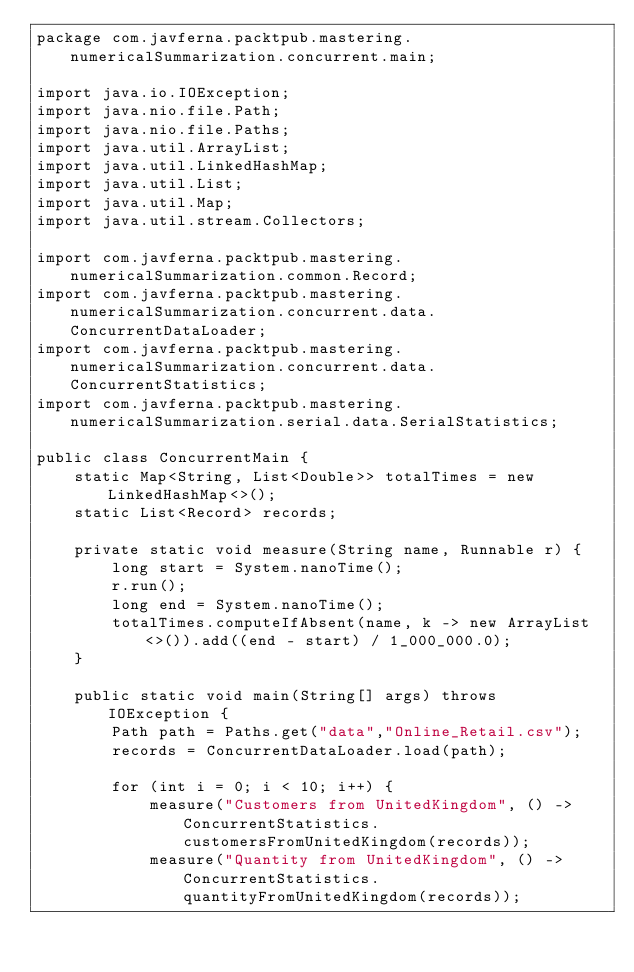Convert code to text. <code><loc_0><loc_0><loc_500><loc_500><_Java_>package com.javferna.packtpub.mastering.numericalSummarization.concurrent.main;

import java.io.IOException;
import java.nio.file.Path;
import java.nio.file.Paths;
import java.util.ArrayList;
import java.util.LinkedHashMap;
import java.util.List;
import java.util.Map;
import java.util.stream.Collectors;

import com.javferna.packtpub.mastering.numericalSummarization.common.Record;
import com.javferna.packtpub.mastering.numericalSummarization.concurrent.data.ConcurrentDataLoader;
import com.javferna.packtpub.mastering.numericalSummarization.concurrent.data.ConcurrentStatistics;
import com.javferna.packtpub.mastering.numericalSummarization.serial.data.SerialStatistics;

public class ConcurrentMain {
	static Map<String, List<Double>> totalTimes = new LinkedHashMap<>();
	static List<Record> records;

	private static void measure(String name, Runnable r) {
		long start = System.nanoTime();
		r.run();
		long end = System.nanoTime();
		totalTimes.computeIfAbsent(name, k -> new ArrayList<>()).add((end - start) / 1_000_000.0);
	}

	public static void main(String[] args) throws IOException {
		Path path = Paths.get("data","Online_Retail.csv");
		records = ConcurrentDataLoader.load(path);

		for (int i = 0; i < 10; i++) {
			measure("Customers from UnitedKingdom", () -> ConcurrentStatistics.customersFromUnitedKingdom(records));
			measure("Quantity from UnitedKingdom", () -> ConcurrentStatistics.quantityFromUnitedKingdom(records));</code> 